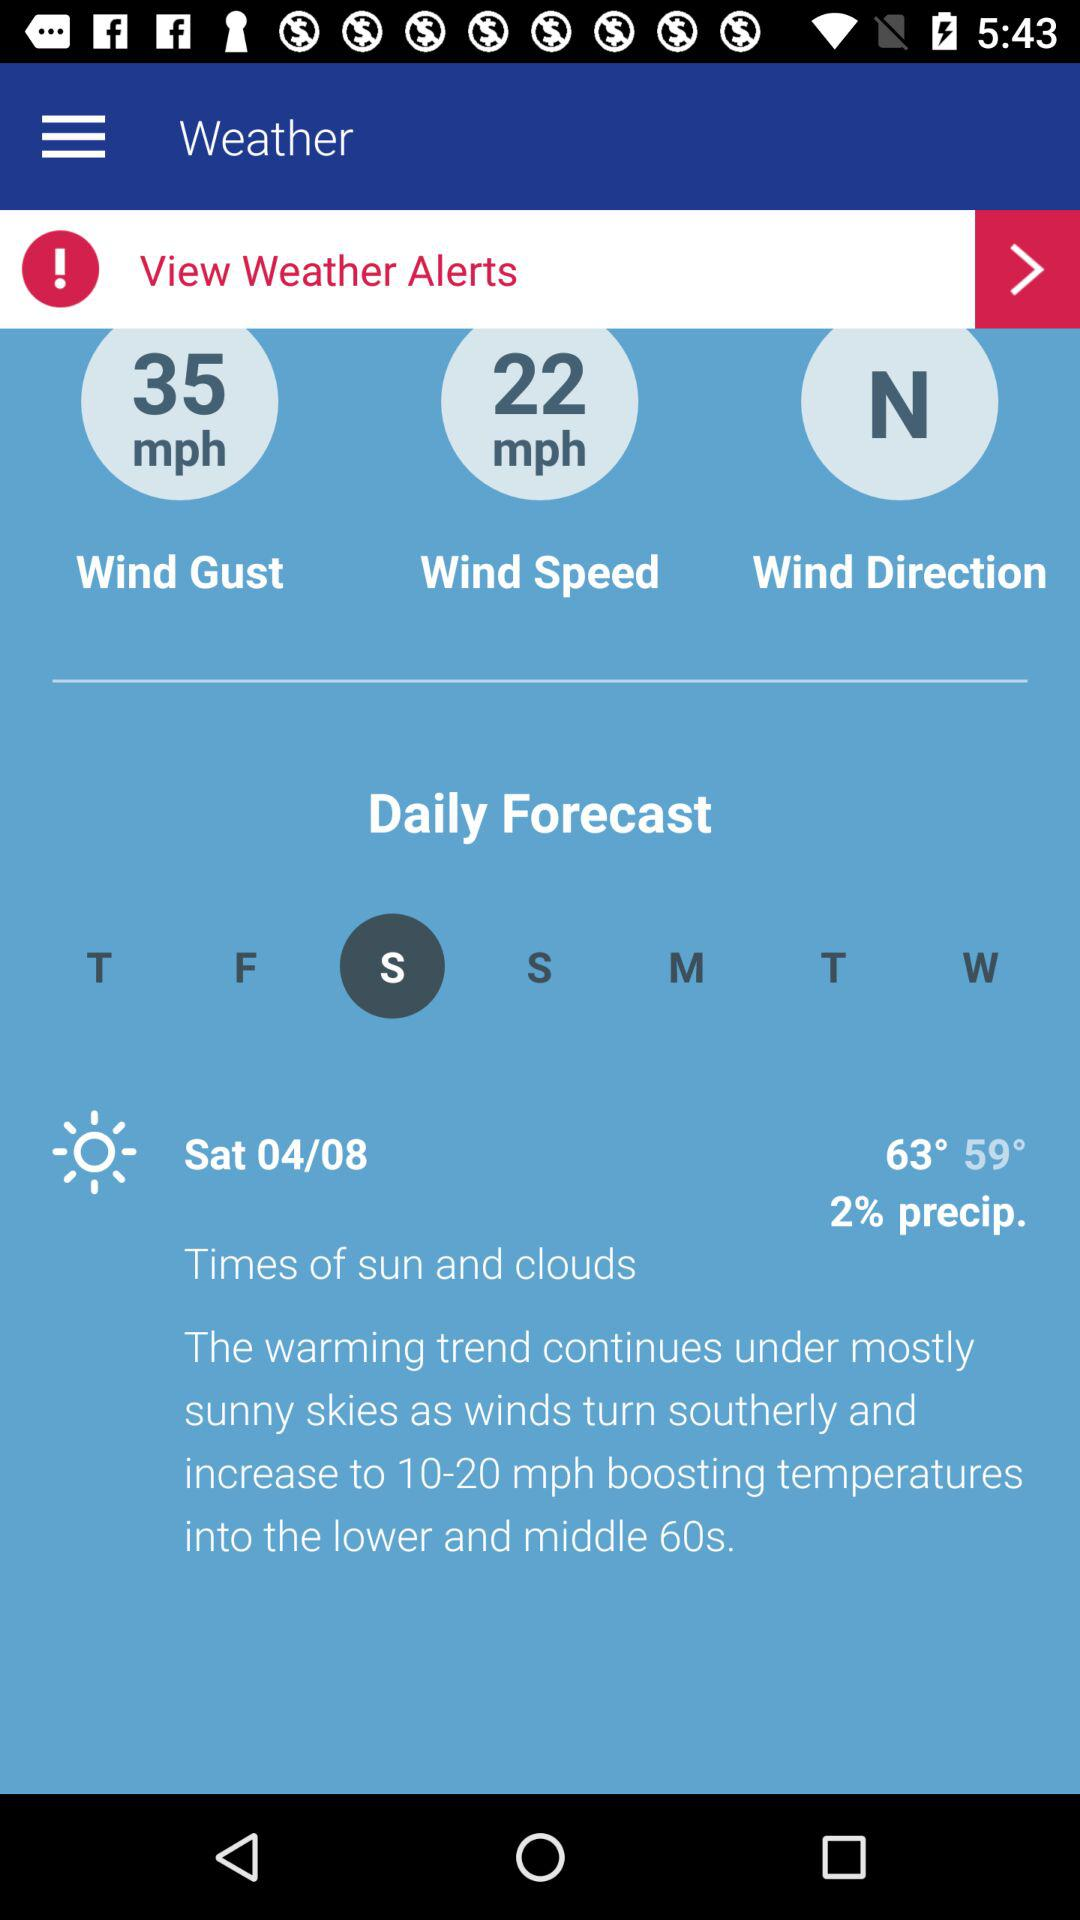What is the highest recorded weather temperature? The highest recorded weather temperature is 63°. 